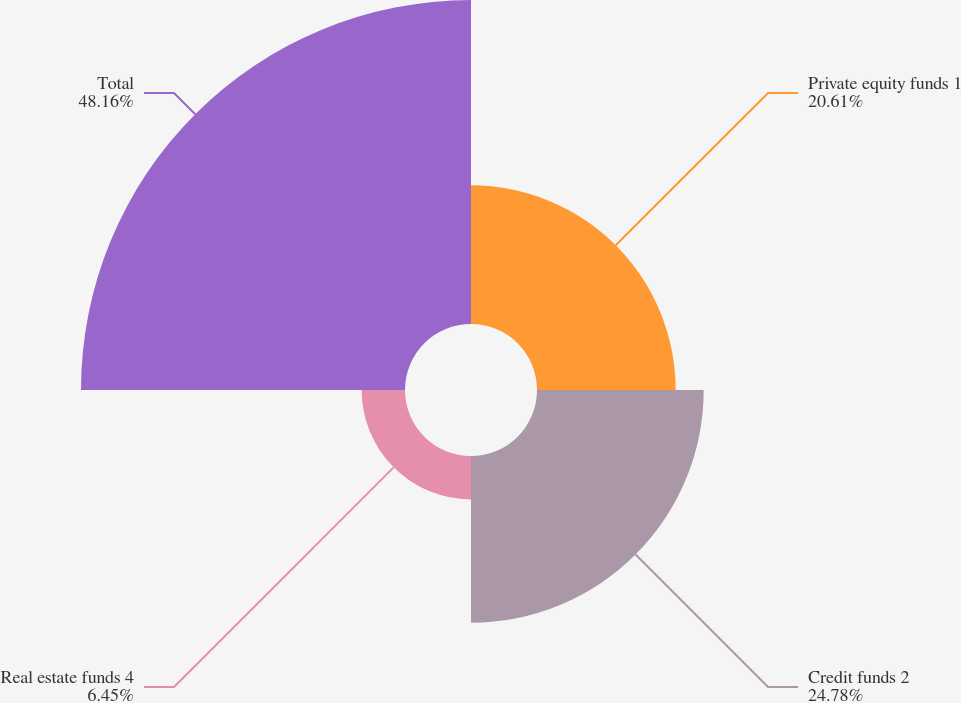<chart> <loc_0><loc_0><loc_500><loc_500><pie_chart><fcel>Private equity funds 1<fcel>Credit funds 2<fcel>Real estate funds 4<fcel>Total<nl><fcel>20.61%<fcel>24.78%<fcel>6.45%<fcel>48.16%<nl></chart> 